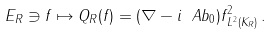Convert formula to latex. <formula><loc_0><loc_0><loc_500><loc_500>E _ { R } \ni f \mapsto Q _ { R } ( f ) = \| ( \nabla - i \ A b _ { 0 } ) f \| _ { L ^ { 2 } ( K _ { R } ) } ^ { 2 } \, .</formula> 